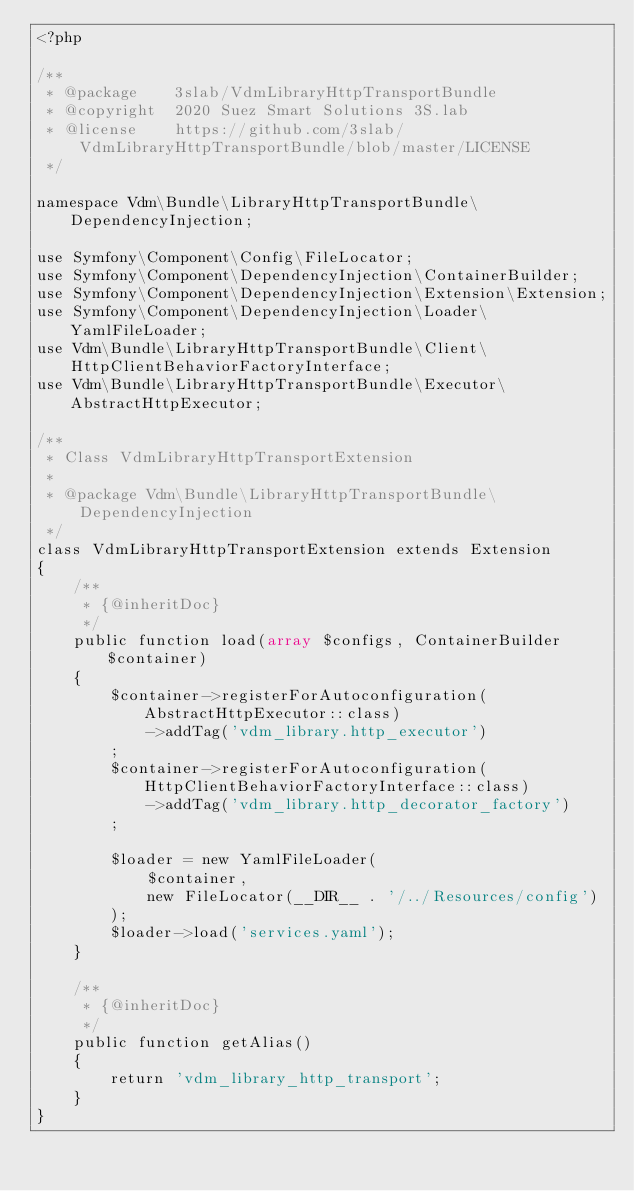<code> <loc_0><loc_0><loc_500><loc_500><_PHP_><?php

/**
 * @package    3slab/VdmLibraryHttpTransportBundle
 * @copyright  2020 Suez Smart Solutions 3S.lab
 * @license    https://github.com/3slab/VdmLibraryHttpTransportBundle/blob/master/LICENSE
 */

namespace Vdm\Bundle\LibraryHttpTransportBundle\DependencyInjection;

use Symfony\Component\Config\FileLocator;
use Symfony\Component\DependencyInjection\ContainerBuilder;
use Symfony\Component\DependencyInjection\Extension\Extension;
use Symfony\Component\DependencyInjection\Loader\YamlFileLoader;
use Vdm\Bundle\LibraryHttpTransportBundle\Client\HttpClientBehaviorFactoryInterface;
use Vdm\Bundle\LibraryHttpTransportBundle\Executor\AbstractHttpExecutor;

/**
 * Class VdmLibraryHttpTransportExtension
 *
 * @package Vdm\Bundle\LibraryHttpTransportBundle\DependencyInjection
 */
class VdmLibraryHttpTransportExtension extends Extension
{
    /**
     * {@inheritDoc}
     */
    public function load(array $configs, ContainerBuilder $container)
    {
        $container->registerForAutoconfiguration(AbstractHttpExecutor::class)
            ->addTag('vdm_library.http_executor')
        ;
        $container->registerForAutoconfiguration(HttpClientBehaviorFactoryInterface::class)
            ->addTag('vdm_library.http_decorator_factory')
        ;

        $loader = new YamlFileLoader(
            $container,
            new FileLocator(__DIR__ . '/../Resources/config')
        );
        $loader->load('services.yaml');
    }

    /**
     * {@inheritDoc}
     */
    public function getAlias()
    {
        return 'vdm_library_http_transport';
    }
}
</code> 